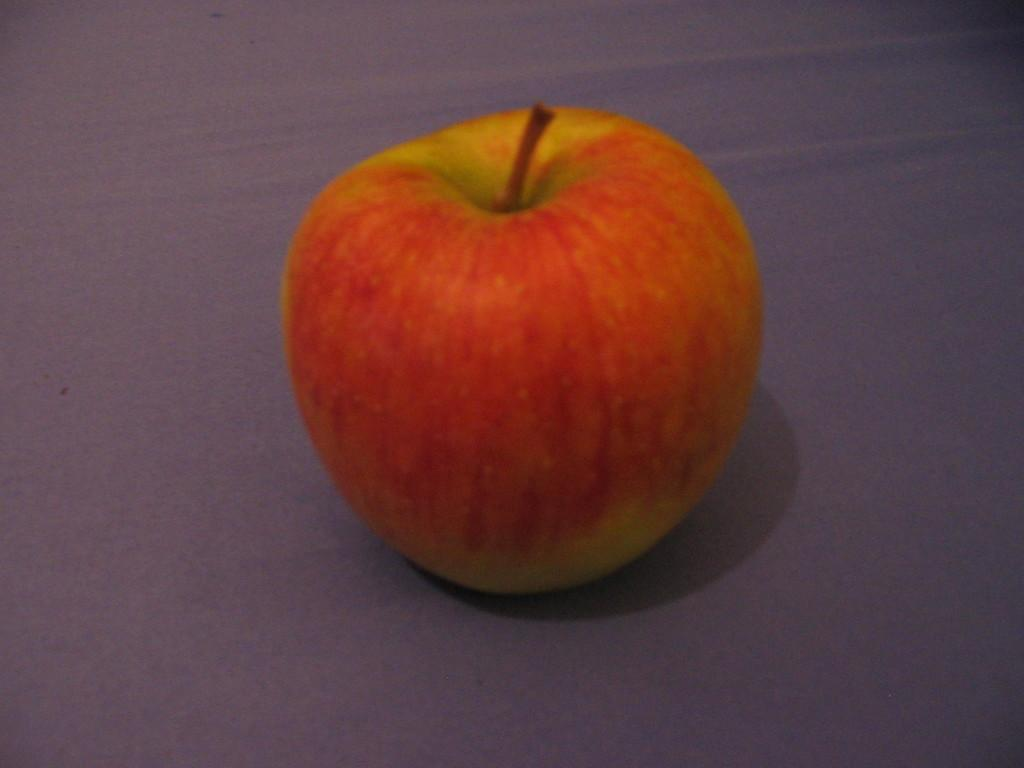What type of fruit is present in the image? There is a red color apple in the image. Where might the apple be placed in the image? The apple might be kept on the floor. What type of bat can be seen flying around the apple in the image? There is no bat present in the image; it only features a red color apple. 